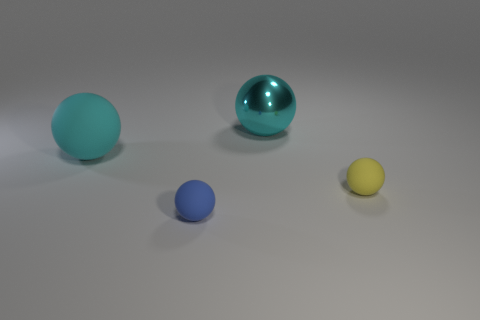Add 1 brown rubber cylinders. How many objects exist? 5 Subtract all blue rubber things. Subtract all blue things. How many objects are left? 2 Add 3 tiny yellow objects. How many tiny yellow objects are left? 4 Add 3 large cyan matte spheres. How many large cyan matte spheres exist? 4 Subtract 0 green balls. How many objects are left? 4 